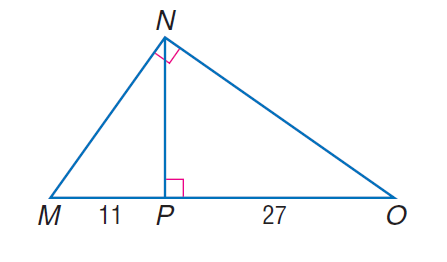Question: Find the measure of the altitude drawn to the hypotenuse.
Choices:
A. 11
B. \sqrt { 297 }
C. 27
D. 297
Answer with the letter. Answer: B 